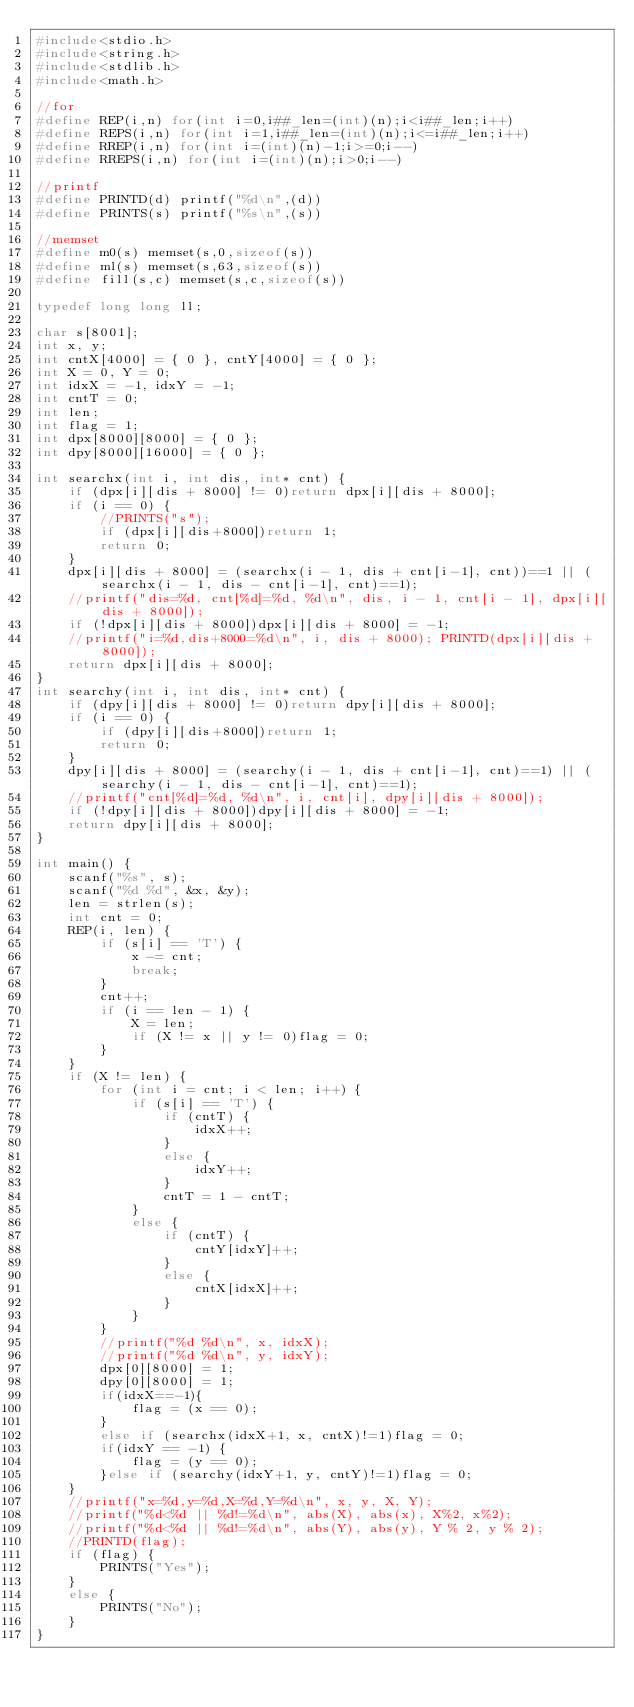<code> <loc_0><loc_0><loc_500><loc_500><_C_>#include<stdio.h>
#include<string.h>
#include<stdlib.h>
#include<math.h>

//for
#define REP(i,n) for(int i=0,i##_len=(int)(n);i<i##_len;i++)
#define REPS(i,n) for(int i=1,i##_len=(int)(n);i<=i##_len;i++)
#define RREP(i,n) for(int i=(int)(n)-1;i>=0;i--)
#define RREPS(i,n) for(int i=(int)(n);i>0;i--)

//printf
#define PRINTD(d) printf("%d\n",(d))
#define PRINTS(s) printf("%s\n",(s))

//memset
#define m0(s) memset(s,0,sizeof(s))
#define ml(s) memset(s,63,sizeof(s))
#define fill(s,c) memset(s,c,sizeof(s))

typedef long long ll;

char s[8001];
int x, y;
int cntX[4000] = { 0 }, cntY[4000] = { 0 };
int X = 0, Y = 0;
int idxX = -1, idxY = -1;
int cntT = 0;
int len;
int flag = 1;
int dpx[8000][8000] = { 0 };
int dpy[8000][16000] = { 0 };

int searchx(int i, int dis, int* cnt) {
	if (dpx[i][dis + 8000] != 0)return dpx[i][dis + 8000];
	if (i == 0) {
		//PRINTS("s");
		if (dpx[i][dis+8000])return 1;
		return 0;
	}
	dpx[i][dis + 8000] = (searchx(i - 1, dis + cnt[i-1], cnt))==1 || (searchx(i - 1, dis - cnt[i-1], cnt)==1);
	//printf("dis=%d, cnt[%d]=%d, %d\n", dis, i - 1, cnt[i - 1], dpx[i][dis + 8000]);
	if (!dpx[i][dis + 8000])dpx[i][dis + 8000] = -1;
	//printf("i=%d,dis+8000=%d\n", i, dis + 8000); PRINTD(dpx[i][dis + 8000]);
	return dpx[i][dis + 8000];
}
int searchy(int i, int dis, int* cnt) {
	if (dpy[i][dis + 8000] != 0)return dpy[i][dis + 8000];
	if (i == 0) {
		if (dpy[i][dis+8000])return 1;
		return 0;
	}
	dpy[i][dis + 8000] = (searchy(i - 1, dis + cnt[i-1], cnt)==1) || (searchy(i - 1, dis - cnt[i-1], cnt)==1);
	//printf("cnt[%d]=%d, %d\n", i, cnt[i], dpy[i][dis + 8000]);
	if (!dpy[i][dis + 8000])dpy[i][dis + 8000] = -1;
	return dpy[i][dis + 8000];
}

int main() {
	scanf("%s", s);
	scanf("%d %d", &x, &y);
	len = strlen(s);
	int cnt = 0;
	REP(i, len) {
		if (s[i] == 'T') {
			x -= cnt;
			break;
		}
		cnt++;
		if (i == len - 1) {
			X = len;
			if (X != x || y != 0)flag = 0;
		}
	}
	if (X != len) {
		for (int i = cnt; i < len; i++) {
			if (s[i] == 'T') {
				if (cntT) {
					idxX++;
				}
				else {
					idxY++;
				}
				cntT = 1 - cntT;
			}
			else {
				if (cntT) {
					cntY[idxY]++;
				}
				else {
					cntX[idxX]++;
				}
			}
		}
		//printf("%d %d\n", x, idxX);
		//printf("%d %d\n", y, idxY);
		dpx[0][8000] = 1;
		dpy[0][8000] = 1;
		if(idxX==-1){
			flag = (x == 0);
		}
		else if (searchx(idxX+1, x, cntX)!=1)flag = 0;
		if(idxY == -1) {
			flag = (y == 0);
		}else if (searchy(idxY+1, y, cntY)!=1)flag = 0;
	}
	//printf("x=%d,y=%d,X=%d,Y=%d\n", x, y, X, Y);
	//printf("%d<%d || %d!=%d\n", abs(X), abs(x), X%2, x%2);
	//printf("%d<%d || %d!=%d\n", abs(Y), abs(y), Y % 2, y % 2);
	//PRINTD(flag);
	if (flag) {
		PRINTS("Yes");
	}
	else {
		PRINTS("No");
	}
}</code> 